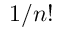Convert formula to latex. <formula><loc_0><loc_0><loc_500><loc_500>1 / n !</formula> 